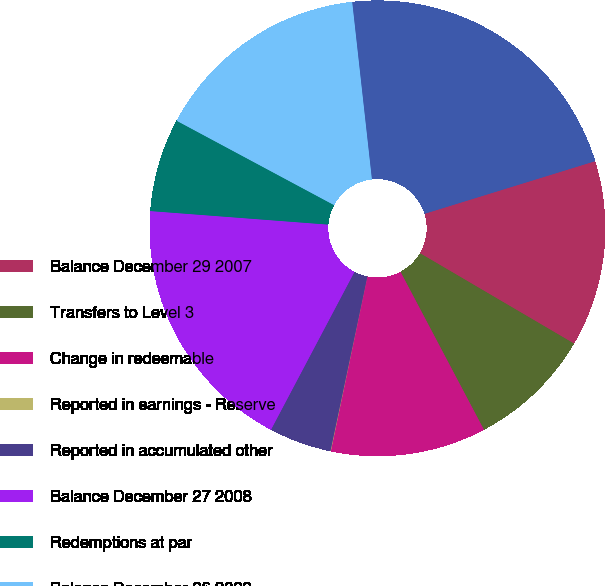Convert chart. <chart><loc_0><loc_0><loc_500><loc_500><pie_chart><fcel>Balance December 29 2007<fcel>Transfers to Level 3<fcel>Change in redeemable<fcel>Reported in earnings - Reserve<fcel>Reported in accumulated other<fcel>Balance December 27 2008<fcel>Redemptions at par<fcel>Balance December 26 2009<fcel>Balance December 25 2010<nl><fcel>13.21%<fcel>8.82%<fcel>11.02%<fcel>0.03%<fcel>4.43%<fcel>18.47%<fcel>6.62%<fcel>15.41%<fcel>22.0%<nl></chart> 